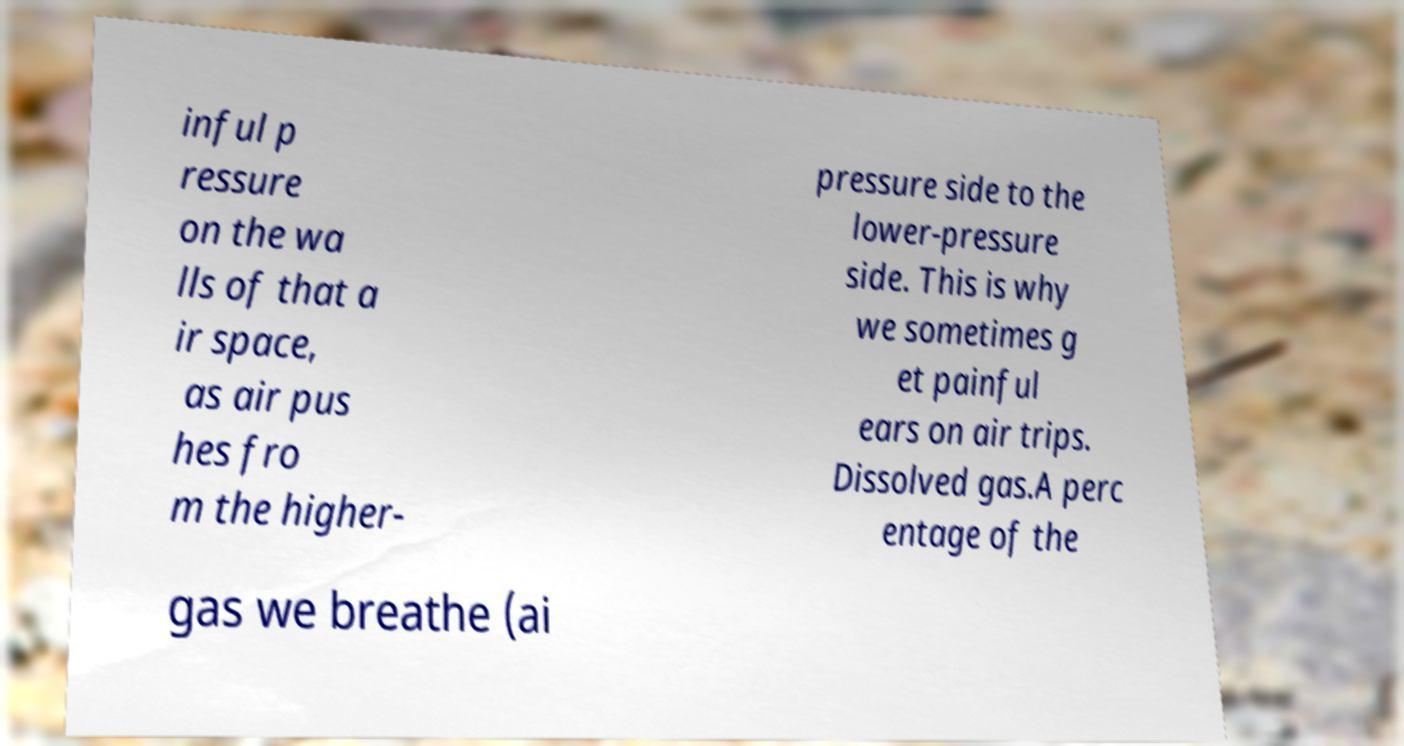There's text embedded in this image that I need extracted. Can you transcribe it verbatim? inful p ressure on the wa lls of that a ir space, as air pus hes fro m the higher- pressure side to the lower-pressure side. This is why we sometimes g et painful ears on air trips. Dissolved gas.A perc entage of the gas we breathe (ai 